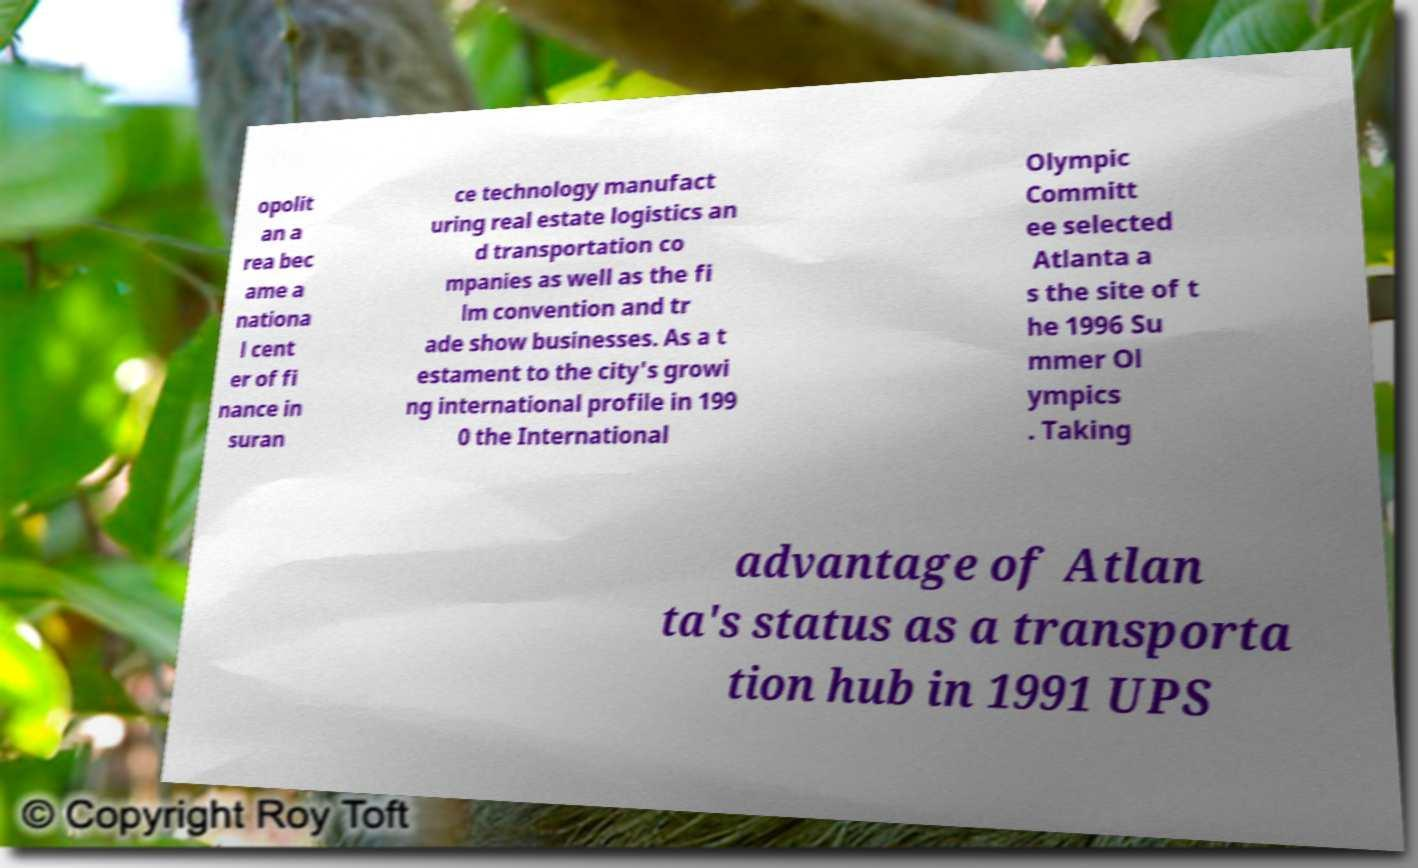Can you read and provide the text displayed in the image?This photo seems to have some interesting text. Can you extract and type it out for me? opolit an a rea bec ame a nationa l cent er of fi nance in suran ce technology manufact uring real estate logistics an d transportation co mpanies as well as the fi lm convention and tr ade show businesses. As a t estament to the city's growi ng international profile in 199 0 the International Olympic Committ ee selected Atlanta a s the site of t he 1996 Su mmer Ol ympics . Taking advantage of Atlan ta's status as a transporta tion hub in 1991 UPS 